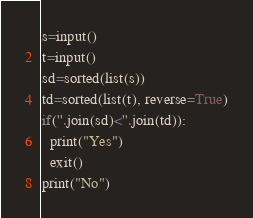Convert code to text. <code><loc_0><loc_0><loc_500><loc_500><_Python_>s=input()
t=input()
sd=sorted(list(s))
td=sorted(list(t), reverse=True)
if(''.join(sd)<''.join(td)):
  print("Yes")
  exit()
print("No")</code> 